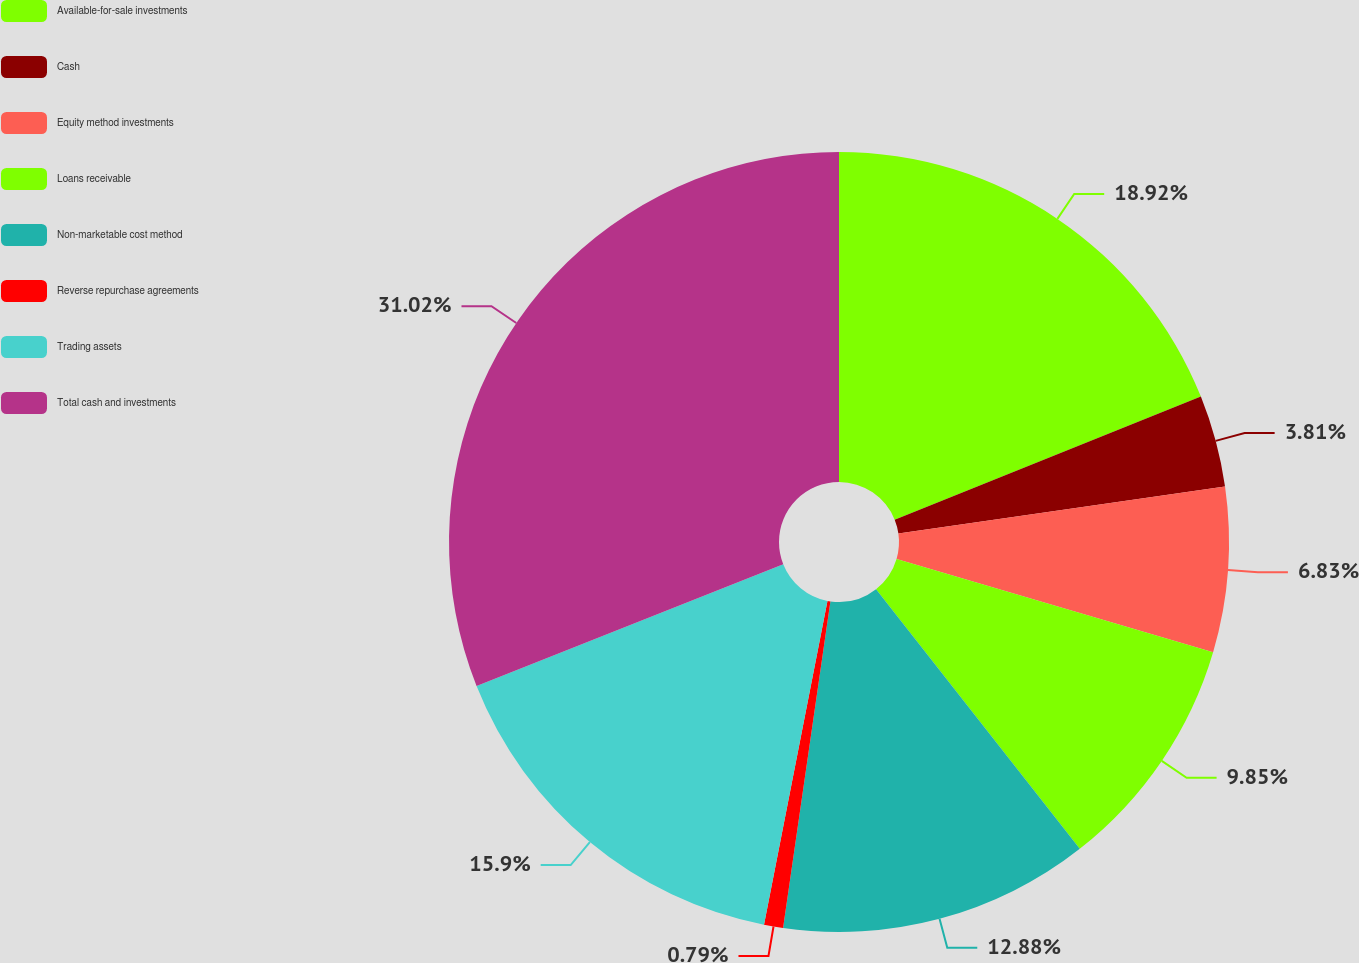<chart> <loc_0><loc_0><loc_500><loc_500><pie_chart><fcel>Available-for-sale investments<fcel>Cash<fcel>Equity method investments<fcel>Loans receivable<fcel>Non-marketable cost method<fcel>Reverse repurchase agreements<fcel>Trading assets<fcel>Total cash and investments<nl><fcel>18.92%<fcel>3.81%<fcel>6.83%<fcel>9.85%<fcel>12.88%<fcel>0.79%<fcel>15.9%<fcel>31.02%<nl></chart> 